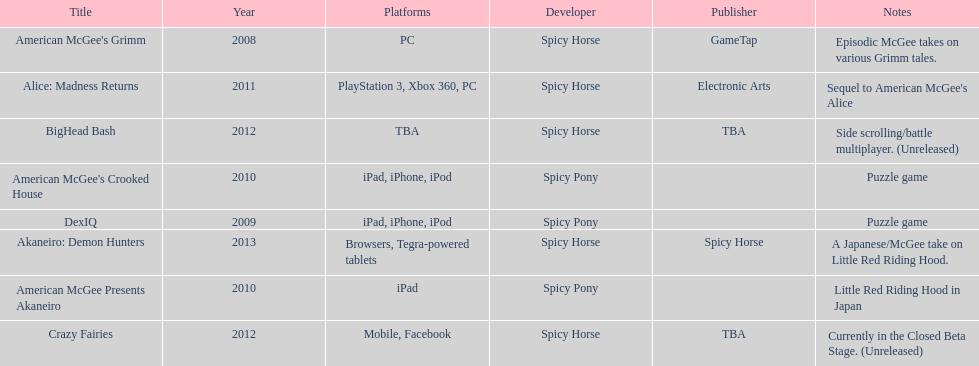How many platforms did american mcgee's grimm run on? 1. 